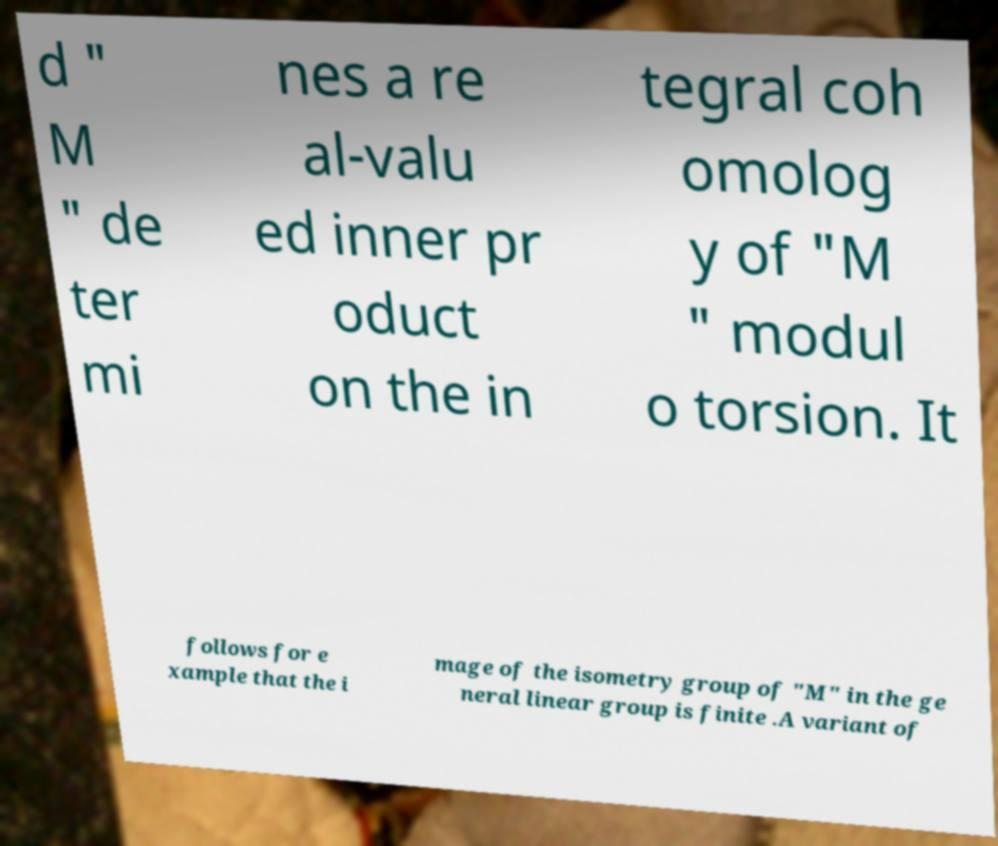Can you accurately transcribe the text from the provided image for me? d " M " de ter mi nes a re al-valu ed inner pr oduct on the in tegral coh omolog y of "M " modul o torsion. It follows for e xample that the i mage of the isometry group of "M" in the ge neral linear group is finite .A variant of 